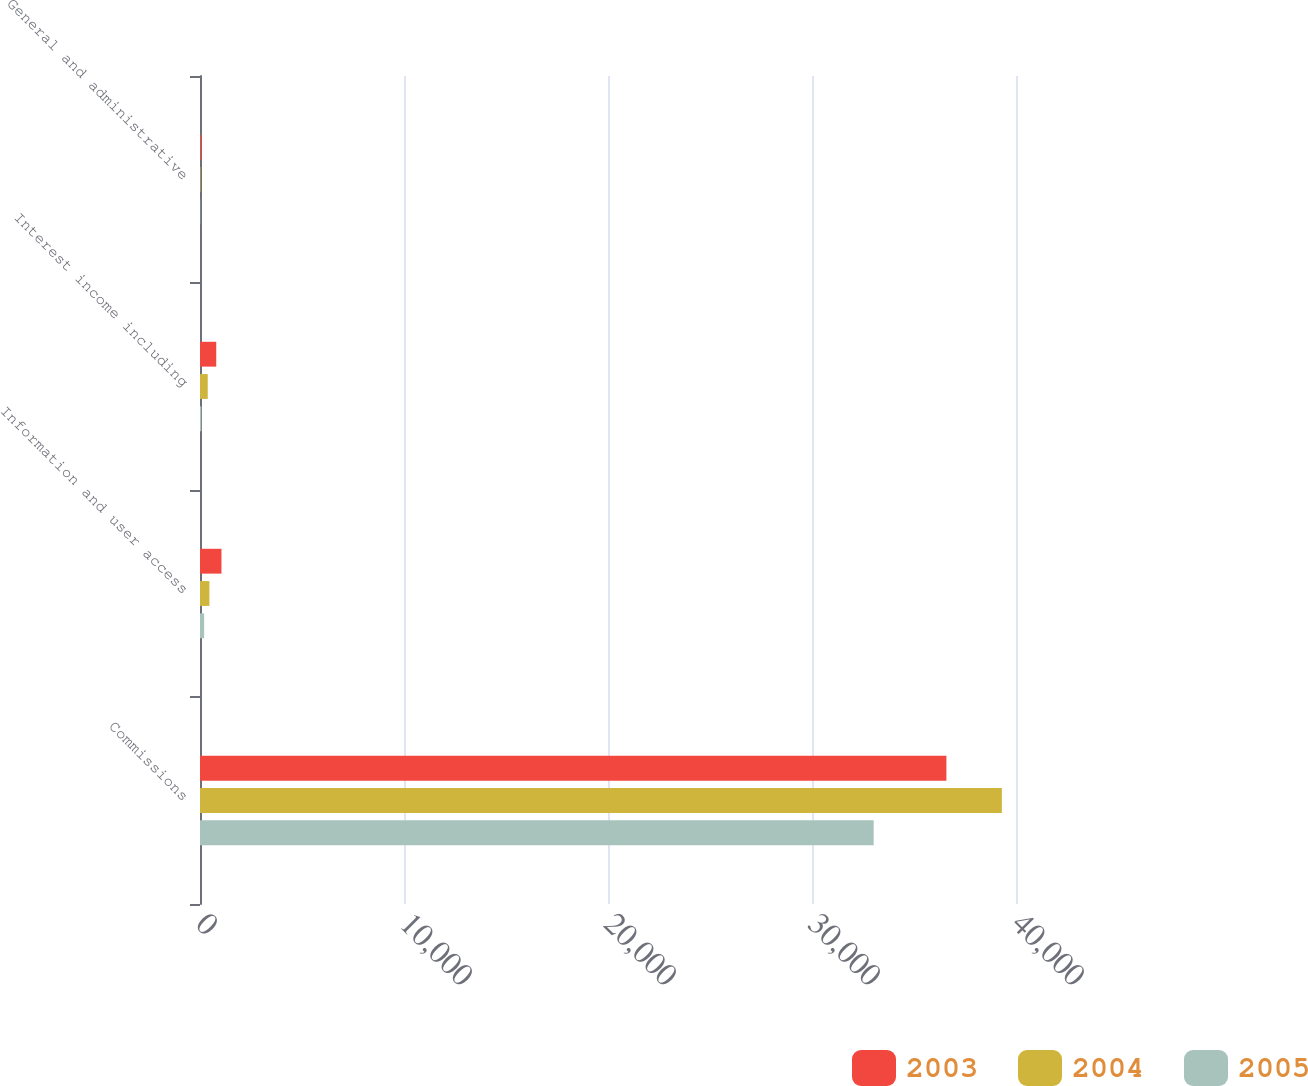Convert chart to OTSL. <chart><loc_0><loc_0><loc_500><loc_500><stacked_bar_chart><ecel><fcel>Commissions<fcel>Information and user access<fcel>Interest income including<fcel>General and administrative<nl><fcel>2003<fcel>36588<fcel>1052<fcel>796<fcel>59<nl><fcel>2004<fcel>39307<fcel>461<fcel>380<fcel>25<nl><fcel>2005<fcel>33023<fcel>203<fcel>65<fcel>12<nl></chart> 